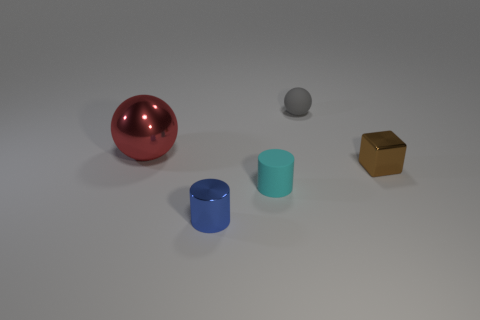How many small metallic cylinders are in front of the small gray ball?
Offer a terse response. 1. Are there fewer matte spheres on the right side of the tiny cube than metal cylinders behind the tiny matte cylinder?
Give a very brief answer. No. The tiny metal object left of the small matte thing that is left of the small gray matte thing that is right of the blue shiny cylinder is what shape?
Provide a short and direct response. Cylinder. There is a metal thing that is to the left of the gray ball and in front of the large sphere; what is its shape?
Offer a very short reply. Cylinder. Is there a cube that has the same material as the gray thing?
Your answer should be very brief. No. What color is the sphere to the right of the blue thing?
Make the answer very short. Gray. Is the shape of the gray matte object the same as the cyan rubber thing that is to the left of the small brown metallic cube?
Your answer should be compact. No. Is there a small cylinder that has the same color as the tiny rubber sphere?
Make the answer very short. No. There is a red thing that is made of the same material as the small brown object; what size is it?
Keep it short and to the point. Large. Is the color of the large object the same as the block?
Your answer should be compact. No. 